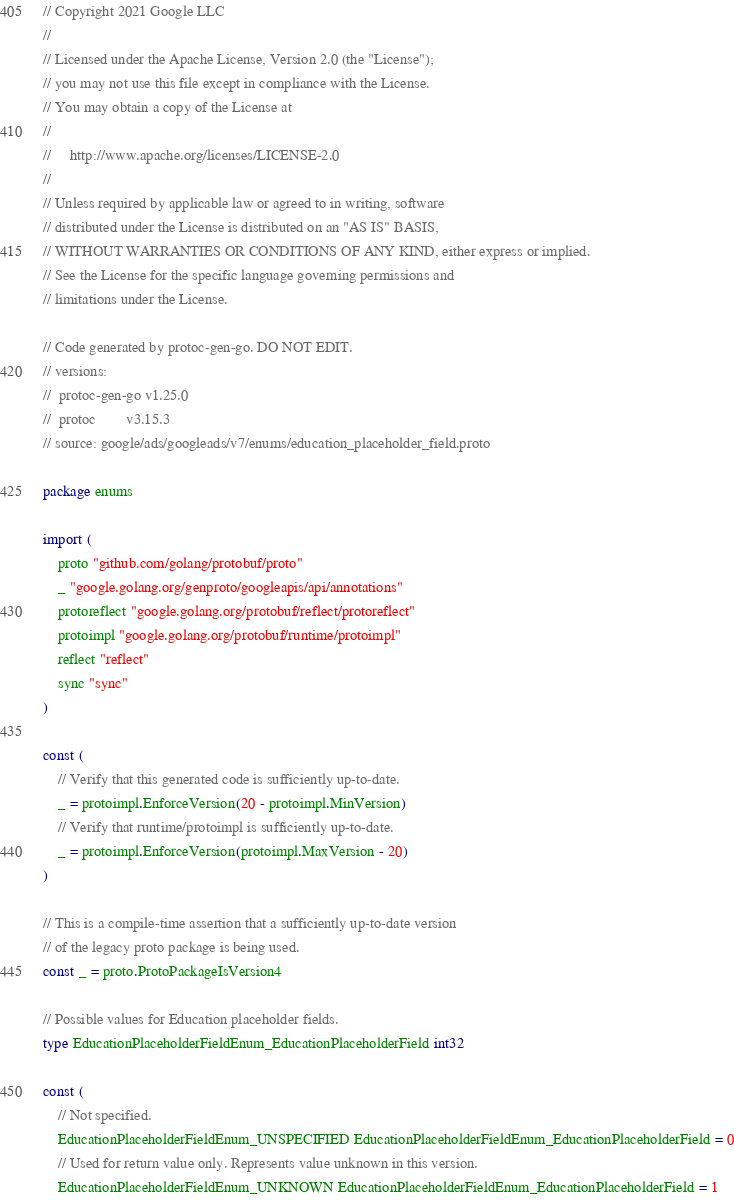<code> <loc_0><loc_0><loc_500><loc_500><_Go_>// Copyright 2021 Google LLC
//
// Licensed under the Apache License, Version 2.0 (the "License");
// you may not use this file except in compliance with the License.
// You may obtain a copy of the License at
//
//     http://www.apache.org/licenses/LICENSE-2.0
//
// Unless required by applicable law or agreed to in writing, software
// distributed under the License is distributed on an "AS IS" BASIS,
// WITHOUT WARRANTIES OR CONDITIONS OF ANY KIND, either express or implied.
// See the License for the specific language governing permissions and
// limitations under the License.

// Code generated by protoc-gen-go. DO NOT EDIT.
// versions:
// 	protoc-gen-go v1.25.0
// 	protoc        v3.15.3
// source: google/ads/googleads/v7/enums/education_placeholder_field.proto

package enums

import (
	proto "github.com/golang/protobuf/proto"
	_ "google.golang.org/genproto/googleapis/api/annotations"
	protoreflect "google.golang.org/protobuf/reflect/protoreflect"
	protoimpl "google.golang.org/protobuf/runtime/protoimpl"
	reflect "reflect"
	sync "sync"
)

const (
	// Verify that this generated code is sufficiently up-to-date.
	_ = protoimpl.EnforceVersion(20 - protoimpl.MinVersion)
	// Verify that runtime/protoimpl is sufficiently up-to-date.
	_ = protoimpl.EnforceVersion(protoimpl.MaxVersion - 20)
)

// This is a compile-time assertion that a sufficiently up-to-date version
// of the legacy proto package is being used.
const _ = proto.ProtoPackageIsVersion4

// Possible values for Education placeholder fields.
type EducationPlaceholderFieldEnum_EducationPlaceholderField int32

const (
	// Not specified.
	EducationPlaceholderFieldEnum_UNSPECIFIED EducationPlaceholderFieldEnum_EducationPlaceholderField = 0
	// Used for return value only. Represents value unknown in this version.
	EducationPlaceholderFieldEnum_UNKNOWN EducationPlaceholderFieldEnum_EducationPlaceholderField = 1</code> 